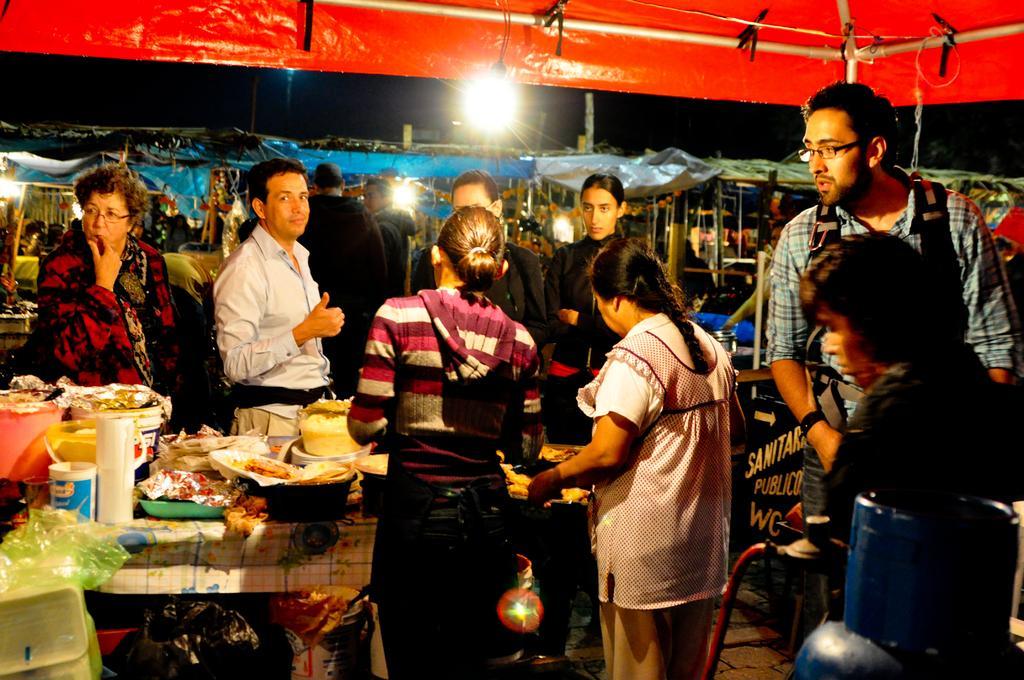In one or two sentences, can you explain what this image depicts? In this image we can see many people. There are tents. Also there are lights. And there is a table with many items. Two persons are wearing specs. Also there are packets. 